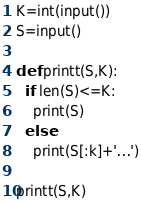<code> <loc_0><loc_0><loc_500><loc_500><_Python_>K=int(input())
S=input()

def printt(S,K):
  if len(S)<=K:
    print(S)
  else:
    print(S[:k]+'...')
      
printt(S,K)
</code> 